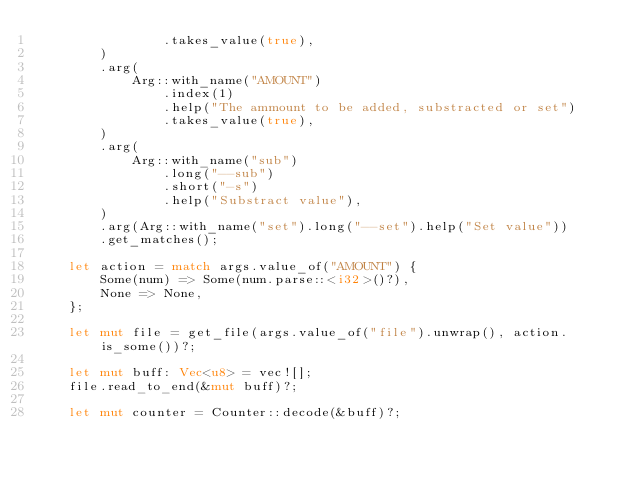Convert code to text. <code><loc_0><loc_0><loc_500><loc_500><_Rust_>                .takes_value(true),
        )
        .arg(
            Arg::with_name("AMOUNT")
                .index(1)
                .help("The ammount to be added, substracted or set")
                .takes_value(true),
        )
        .arg(
            Arg::with_name("sub")
                .long("--sub")
                .short("-s")
                .help("Substract value"),
        )
        .arg(Arg::with_name("set").long("--set").help("Set value"))
        .get_matches();

    let action = match args.value_of("AMOUNT") {
        Some(num) => Some(num.parse::<i32>()?),
        None => None,
    };

    let mut file = get_file(args.value_of("file").unwrap(), action.is_some())?;

    let mut buff: Vec<u8> = vec![];
    file.read_to_end(&mut buff)?;

    let mut counter = Counter::decode(&buff)?;
</code> 